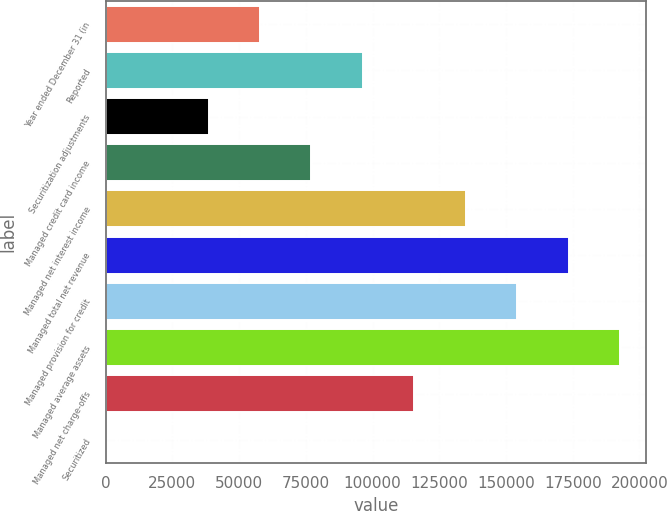Convert chart. <chart><loc_0><loc_0><loc_500><loc_500><bar_chart><fcel>Year ended December 31 (in<fcel>Reported<fcel>Securitization adjustments<fcel>Managed credit card income<fcel>Managed net interest income<fcel>Managed total net revenue<fcel>Managed provision for credit<fcel>Managed average assets<fcel>Managed net charge-offs<fcel>Securitized<nl><fcel>57830<fcel>96378.3<fcel>38555.8<fcel>77104.1<fcel>134927<fcel>173475<fcel>154201<fcel>192749<fcel>115652<fcel>7.55<nl></chart> 